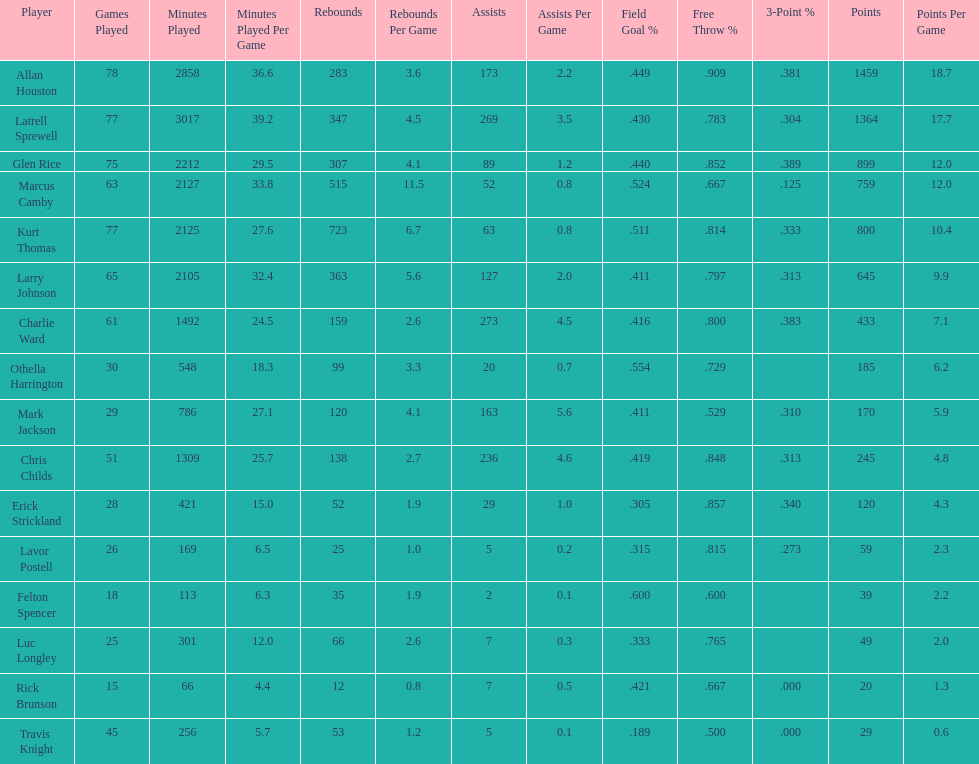How many games did larry johnson play? 65. 